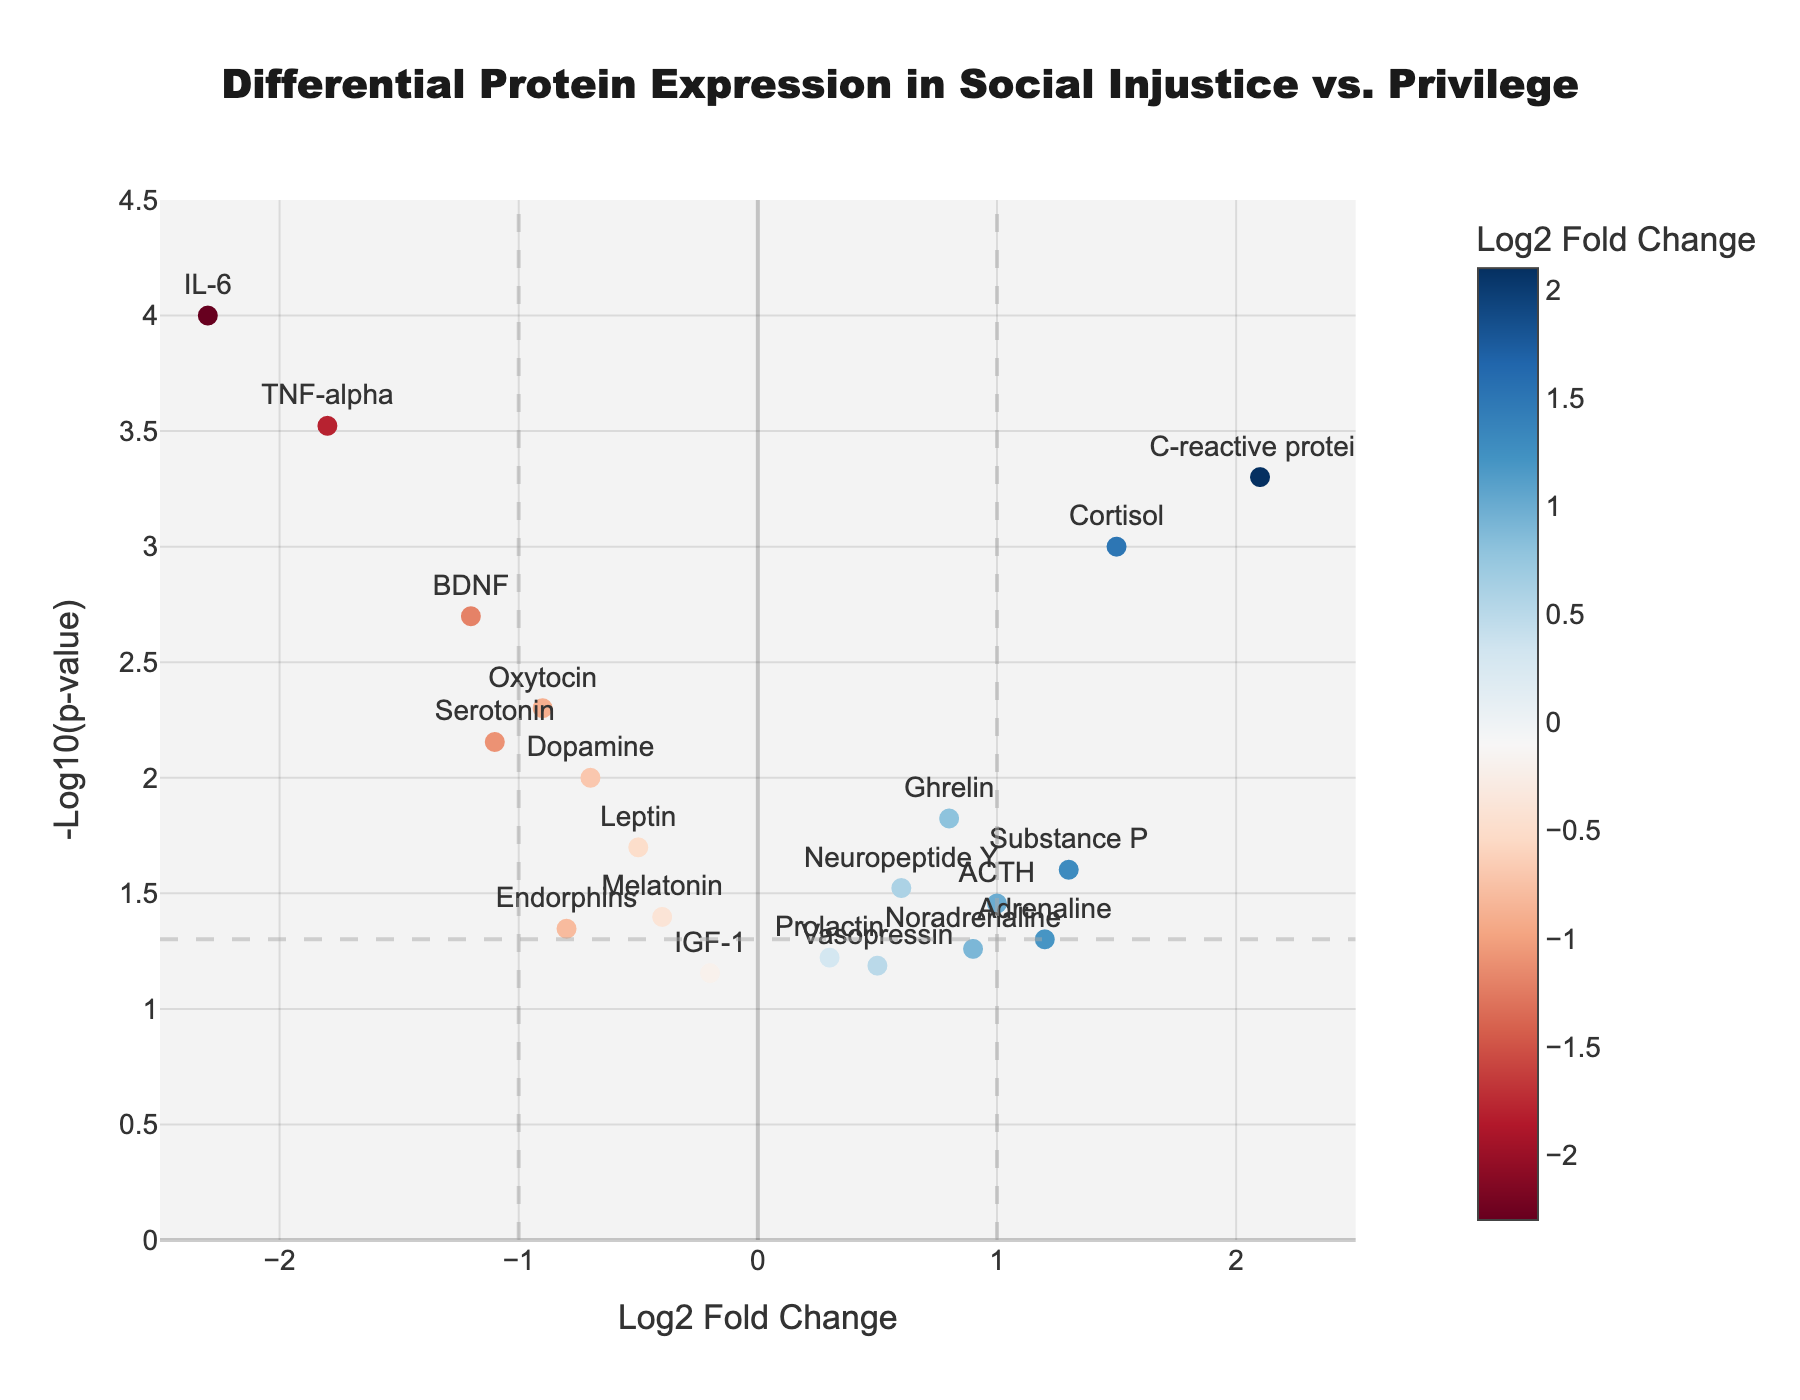What is the main title of the figure? The main title is located at the top of the figure and typically provides a summary of what the plot represents. In this case, the title describes the comparison of protein expression levels between individuals exposed to social injustice versus those in privileged positions.
Answer: Differential Protein Expression in Social Injustice vs. Privilege What are the x-axis and y-axis labels? The x-axis label is found along the horizontal axis and indicates the fold changes in protein expression on a log2 scale, while the y-axis label along the vertical axis represents the p-values on a -log10 scale.
Answer: x-axis: Log2 Fold Change, y-axis: -Log10(p-value) Which protein has the highest -log10(p-value)? To find the protein with the highest -log10(p-value), we look for the highest point on the y-axis. From the plot, the marker at the highest y-coordinate corresponds to IL-6.
Answer: IL-6 What is the log2 fold change and p-value of C-reactive protein? Hovering over the point labeled "C-reactive protein" gives the log2 fold change and p-value. C-reactive protein has a log2 fold change of 2.1 and a p-value of 0.0005.
Answer: Log2 Fold Change: 2.1, p-value: 0.0005 How many proteins have a log2 fold change less than -1? To find the number of proteins with log2 fold change less than -1, count the markers left of the -1 threshold line. The proteins are IL-6, TNF-alpha, and BDNF.
Answer: 3 proteins Which proteins have a significant differential expression (p-value < 0.05) but are not upregulated? We look for proteins below the horizontal significance line (-log10(0.05)) with a negative log2 fold change. These include IL-6, TNF-alpha, BDNF, Oxytocin, and Serotonin.
Answer: IL-6, TNF-alpha, BDNF, Oxytocin, Serotonin Which protein exhibits the largest absolute log2 fold change and what is its value? To find the largest absolute log2 fold change, check for the protein furthest from zero on the x-axis. IL-6 has the largest absolute value at -2.3.
Answer: IL-6 with log2 fold change of -2.3 Between Substance P and Adrenaline, which has the smaller p-value? Comparing Substance P and Adrenaline points, Substance P has a higher y-coordinate than Adrenaline, indicating a smaller p-value.
Answer: Substance P with p-value of 0.025 What is the significance threshold for p-values in this plot? The significance threshold is visually represented by the horizontal dashed line on the y-axis, set at -log10(p-value) = -log10(0.05).
Answer: 0.05 